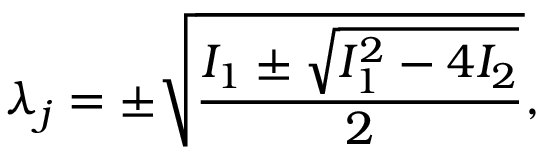Convert formula to latex. <formula><loc_0><loc_0><loc_500><loc_500>\lambda _ { j } = \pm \sqrt { \frac { I _ { 1 } \pm \sqrt { I _ { 1 } ^ { 2 } - 4 I _ { 2 } } } { 2 } } ,</formula> 